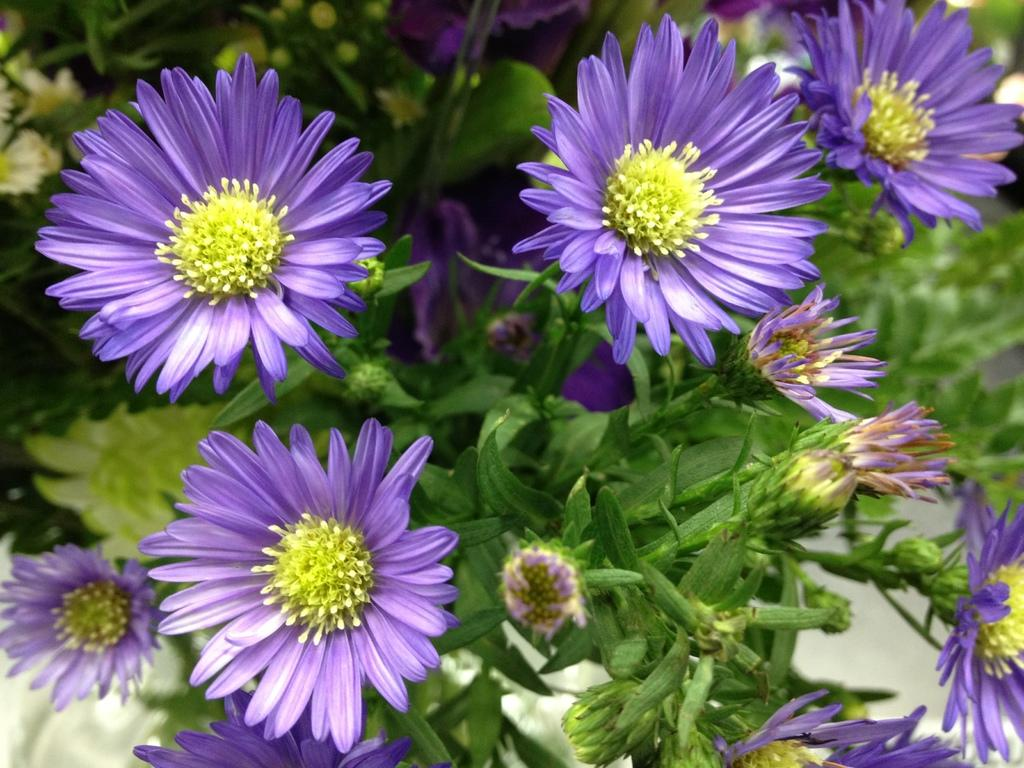What type of living organisms can be seen in the image? There are flowers and plants visible in the image. Can you describe the stage of growth for some of the plants in the image? Yes, there are buds in the image, which are indicative of plants in the early stages of growth. What is the background of the image like? The background of the image is blurred. How many rings are visible on the coach's fingers in the image? There are no rings or coaches present in the image; it features flowers and plants with a blurred background. 